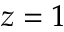<formula> <loc_0><loc_0><loc_500><loc_500>z = 1</formula> 